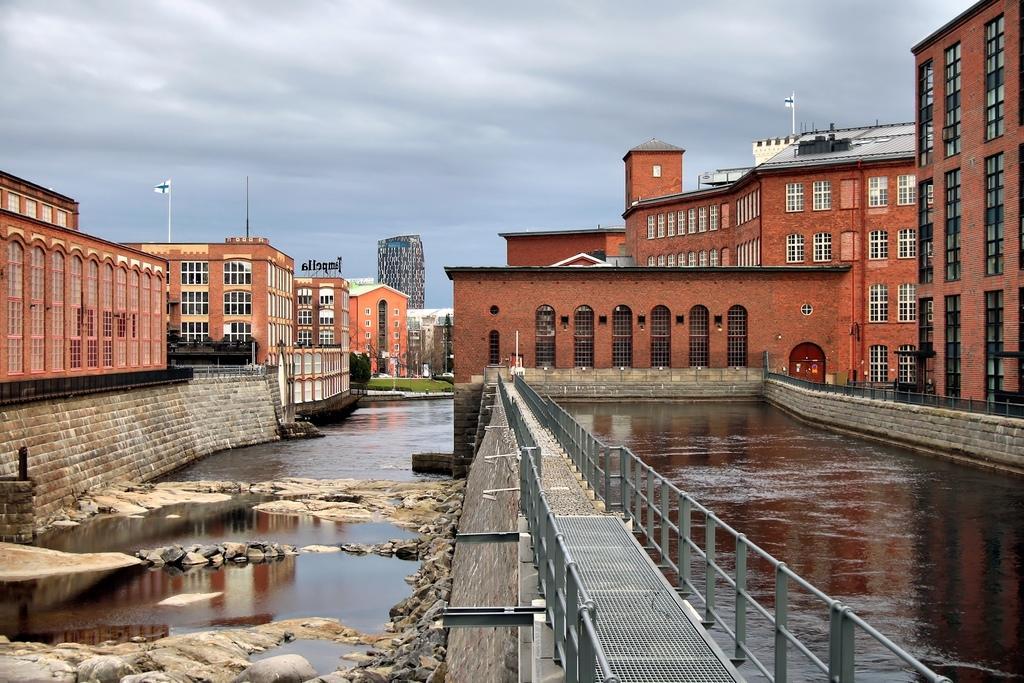Please provide a concise description of this image. There is a bridge at the bottom of this image. We can see trees in the middle of this image and the sky is at the top of this image. We can see water on the left side of this image and on the right side of this image as well. 